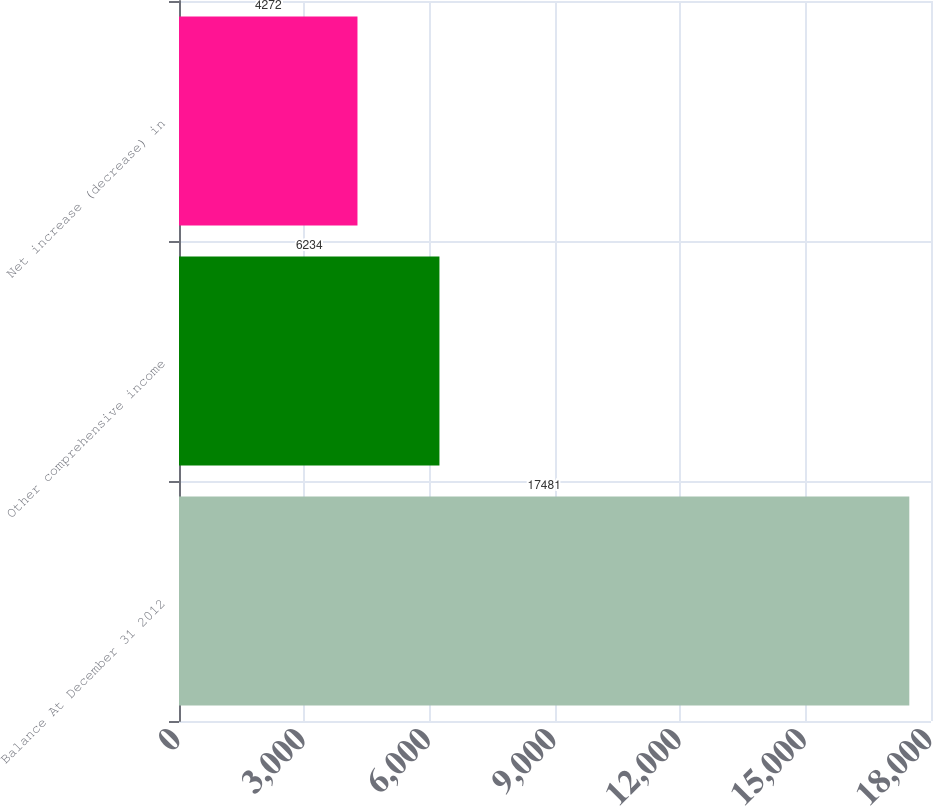Convert chart to OTSL. <chart><loc_0><loc_0><loc_500><loc_500><bar_chart><fcel>Balance At December 31 2012<fcel>Other comprehensive income<fcel>Net increase (decrease) in<nl><fcel>17481<fcel>6234<fcel>4272<nl></chart> 